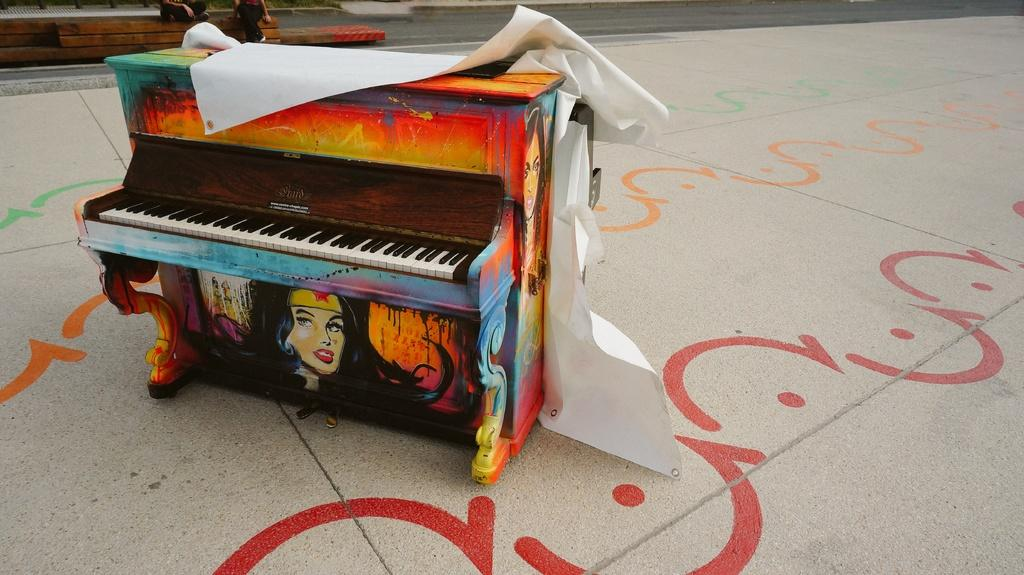What musical instrument is present in the image? There is a piano in the image. What is depicted on the piano? There is an image of a woman on the piano. What is placed on top of the piano? There is a sheet on the piano. What can be seen in the background of the image? There is a road visible in the image. Where is the piano located in relation to the road? The piano is placed on the path. What type of grain can be seen growing in the wilderness near the piano? There is no wilderness or grain present in the image; it features a piano with an image on it, a sheet, and a road in the background. 